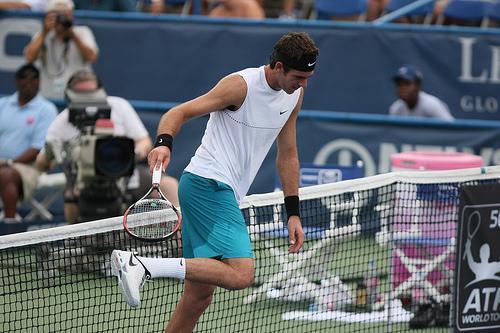How many players are there?
Give a very brief answer. 1. 